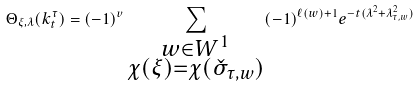Convert formula to latex. <formula><loc_0><loc_0><loc_500><loc_500>\Theta _ { \xi , \lambda } ( k _ { t } ^ { \tau } ) = ( - 1 ) ^ { v } \sum _ { \substack { w \in W ^ { 1 } \\ \chi ( \xi ) = \chi ( \check { \sigma } _ { \tau , w } ) } } ( - 1 ) ^ { \ell ( w ) + 1 } e ^ { - t ( \lambda ^ { 2 } + \lambda _ { \tau , w } ^ { 2 } ) }</formula> 